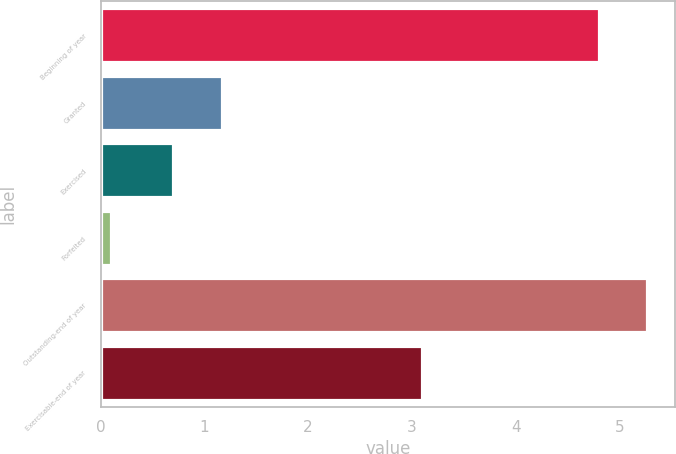Convert chart to OTSL. <chart><loc_0><loc_0><loc_500><loc_500><bar_chart><fcel>Beginning of year<fcel>Granted<fcel>Exercised<fcel>Forfeited<fcel>Outstanding-end of year<fcel>Exercisable-end of year<nl><fcel>4.8<fcel>1.17<fcel>0.7<fcel>0.1<fcel>5.27<fcel>3.1<nl></chart> 